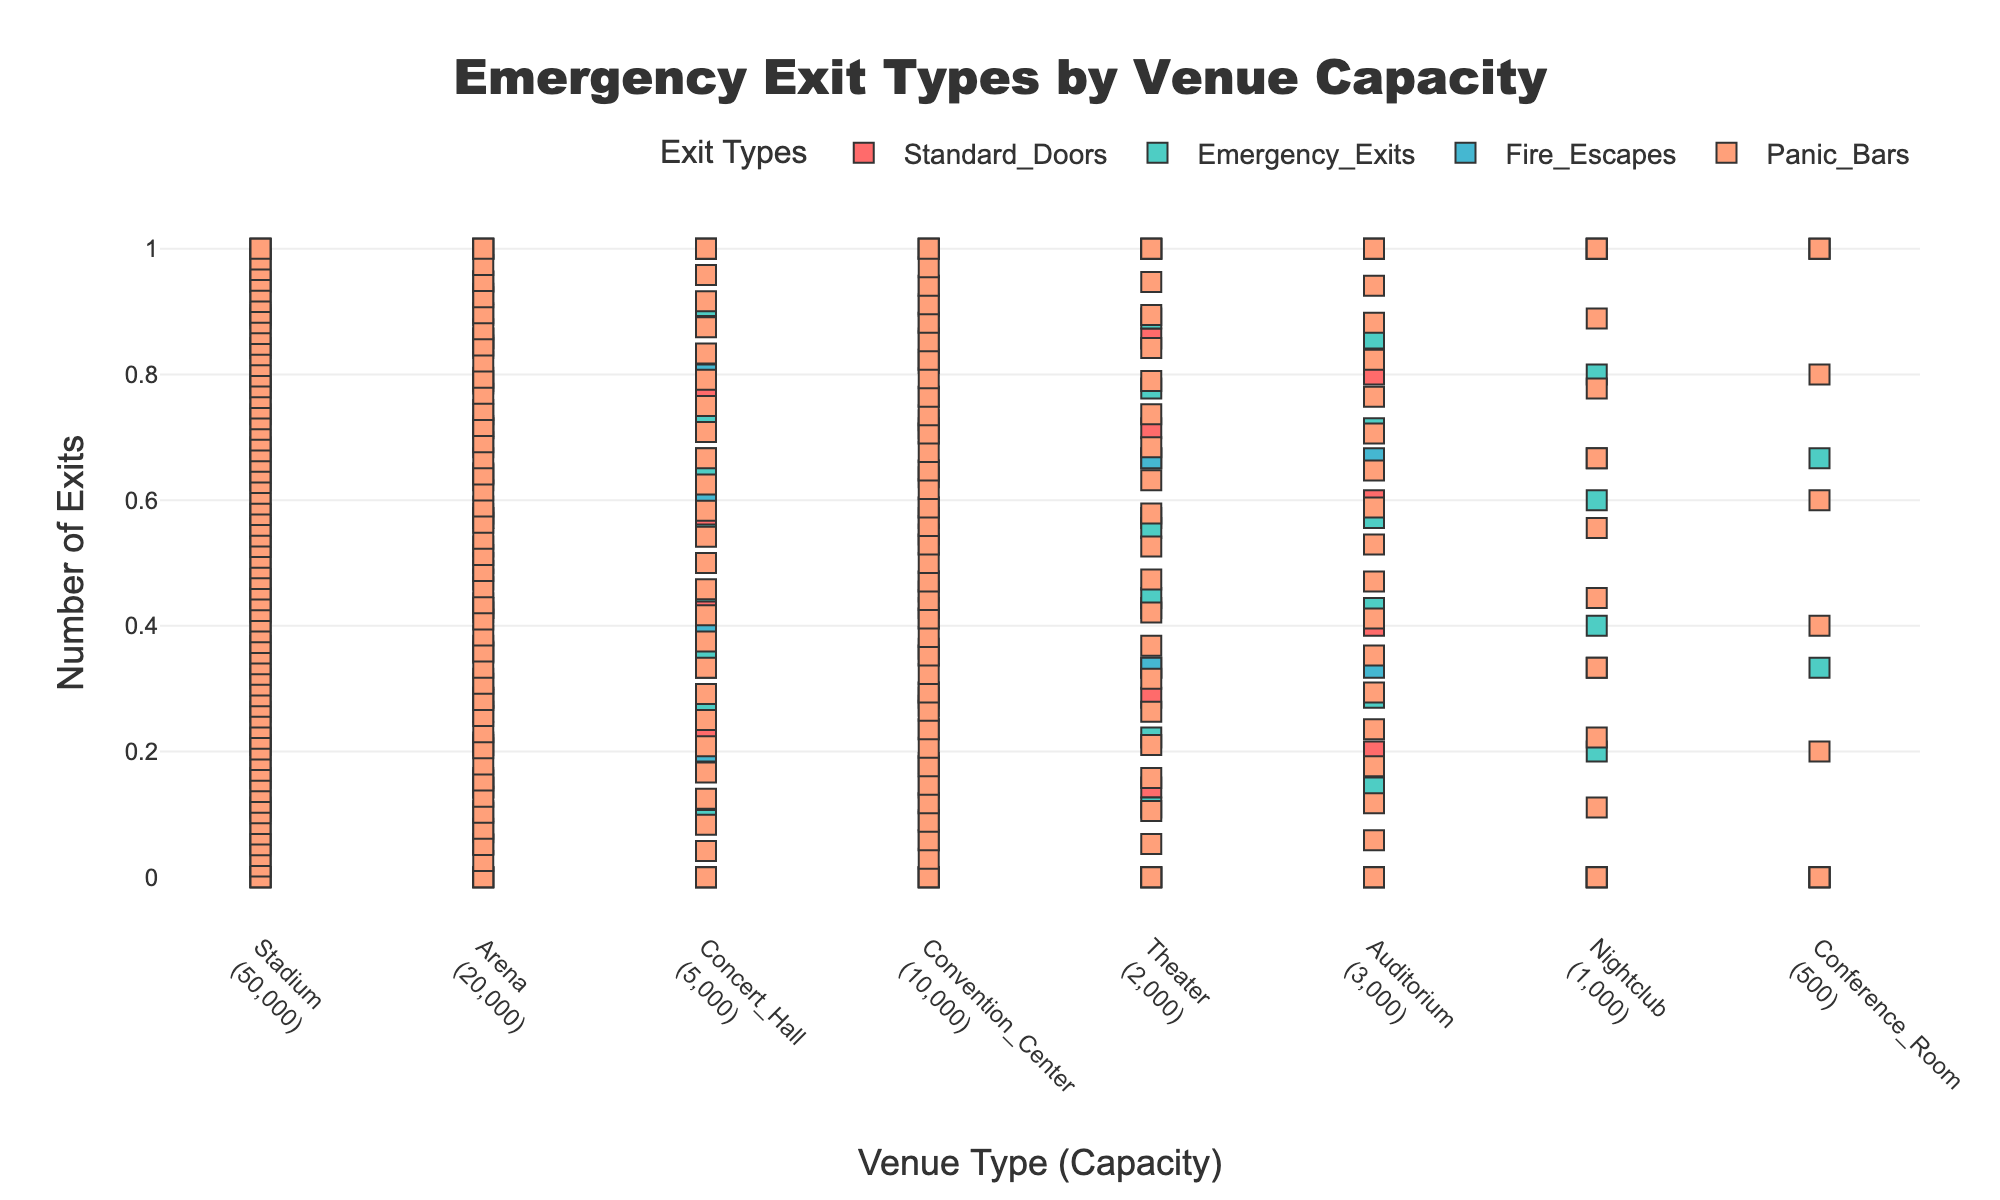Which venue has the highest capacity? By looking at the x-axis labels, we see the capacities are mentioned alongside the venue types. The "Stadium" has a capacity of 50,000, which is the highest among all venues shown.
Answer: Stadium How many types of exits are listed in the plot? From the legend and different colors used for markers, we can count the types of exits: Standard_Doors, Emergency_Exits, Fire_Escapes, and Panic_Bars.
Answer: 4 What type of exit is most common in an Arena? By observing the Arena's exit data, we can see the markers for Panic_Bars (in blue) are most numerous within that venue.
Answer: Panic_Bars What's the total number of exits for the Concert Hall? Summing the number of markers for all exit types in the Concert Hall: 10 (Standard_Doors) + 12 (Emergency_Exits) + 6 (Fire_Escapes) + 25 (Panic_Bars) = 53
Answer: 53 Which exit type has the fewest markers in the Nightclub? By observing the Nightclub's exit data, we see that Fire_Escapes (in green) have the fewest markers compared to other types.
Answer: Fire_Escapes Compare the number of Standard_Doors in the Stadium to that in the Conference Room. By counting the markers for Standard_Doors, the Stadium has 20 and the Conference Room has 2. Thus, the Stadium has 18 more.
Answer: 18 more in Stadium How does the number of Panic Bars in the Theater compare to those in the Auditorium? The Theater has 20 Panic_Bars while the Auditorium has 18. So, the Theater has 2 more Panic_Bars than the Auditorium.
Answer: 2 more in Theater Which venue has more Emergency Exits, the Convention Center or the Arena? By observing the figures for Emergency Exits, the Convention Center has 18 while the Arena has 20. So, the Arena has more Emergency Exits.
Answer: Arena What is the total number of exits across all venues? Adding up all exits across all venues: 271 (sum of all figures within each exit type per venue).
Answer: 271 